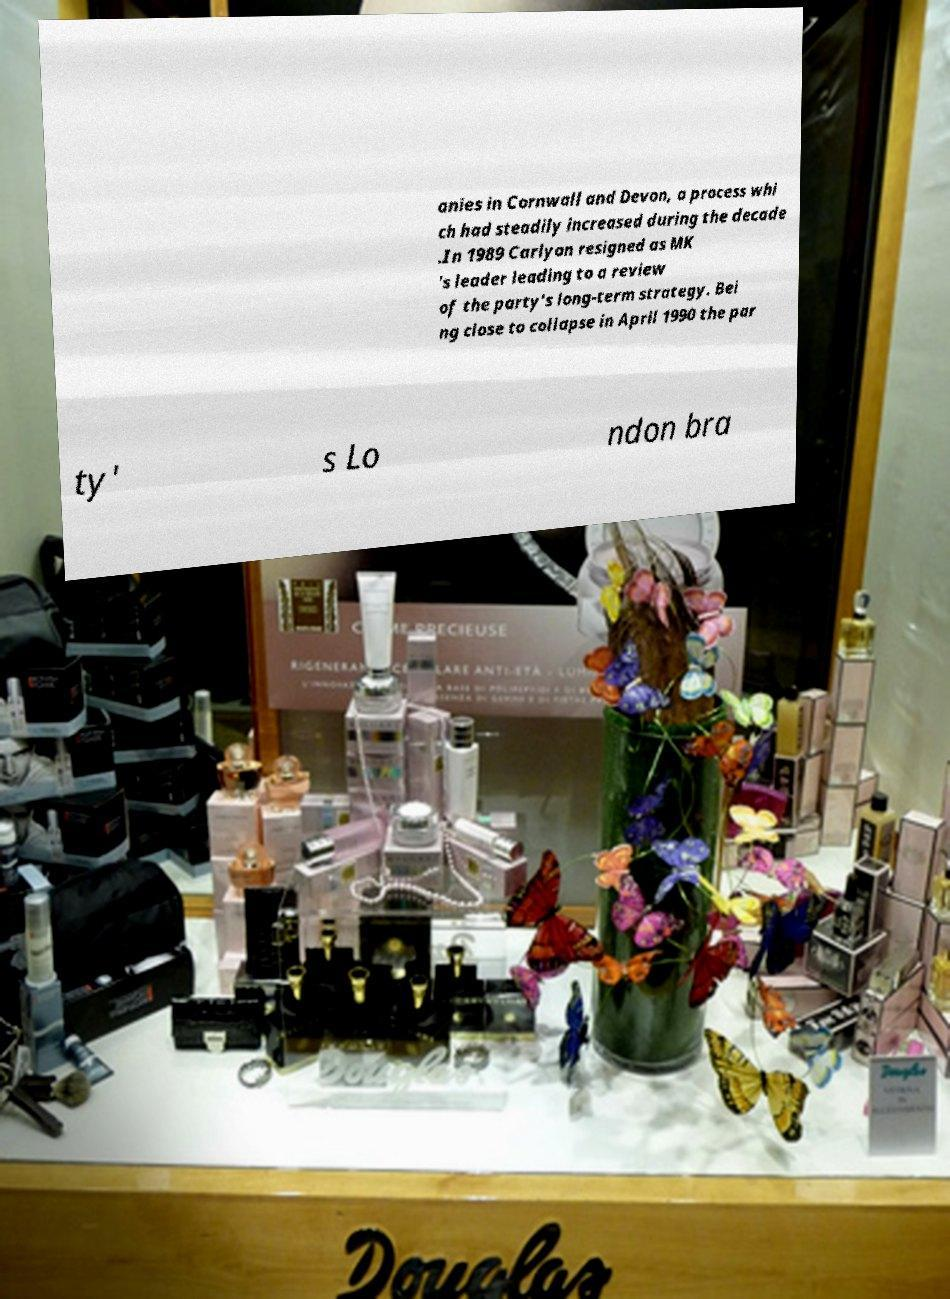Could you extract and type out the text from this image? anies in Cornwall and Devon, a process whi ch had steadily increased during the decade .In 1989 Carlyon resigned as MK 's leader leading to a review of the party's long-term strategy. Bei ng close to collapse in April 1990 the par ty' s Lo ndon bra 